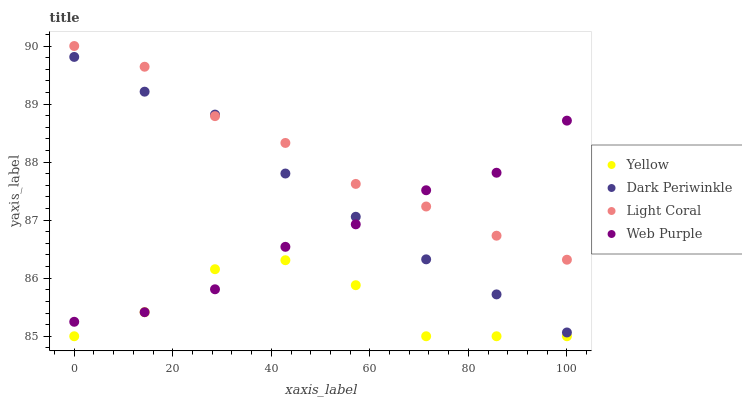Does Yellow have the minimum area under the curve?
Answer yes or no. Yes. Does Light Coral have the maximum area under the curve?
Answer yes or no. Yes. Does Web Purple have the minimum area under the curve?
Answer yes or no. No. Does Web Purple have the maximum area under the curve?
Answer yes or no. No. Is Dark Periwinkle the smoothest?
Answer yes or no. Yes. Is Yellow the roughest?
Answer yes or no. Yes. Is Web Purple the smoothest?
Answer yes or no. No. Is Web Purple the roughest?
Answer yes or no. No. Does Yellow have the lowest value?
Answer yes or no. Yes. Does Web Purple have the lowest value?
Answer yes or no. No. Does Light Coral have the highest value?
Answer yes or no. Yes. Does Web Purple have the highest value?
Answer yes or no. No. Is Yellow less than Light Coral?
Answer yes or no. Yes. Is Light Coral greater than Yellow?
Answer yes or no. Yes. Does Web Purple intersect Light Coral?
Answer yes or no. Yes. Is Web Purple less than Light Coral?
Answer yes or no. No. Is Web Purple greater than Light Coral?
Answer yes or no. No. Does Yellow intersect Light Coral?
Answer yes or no. No. 